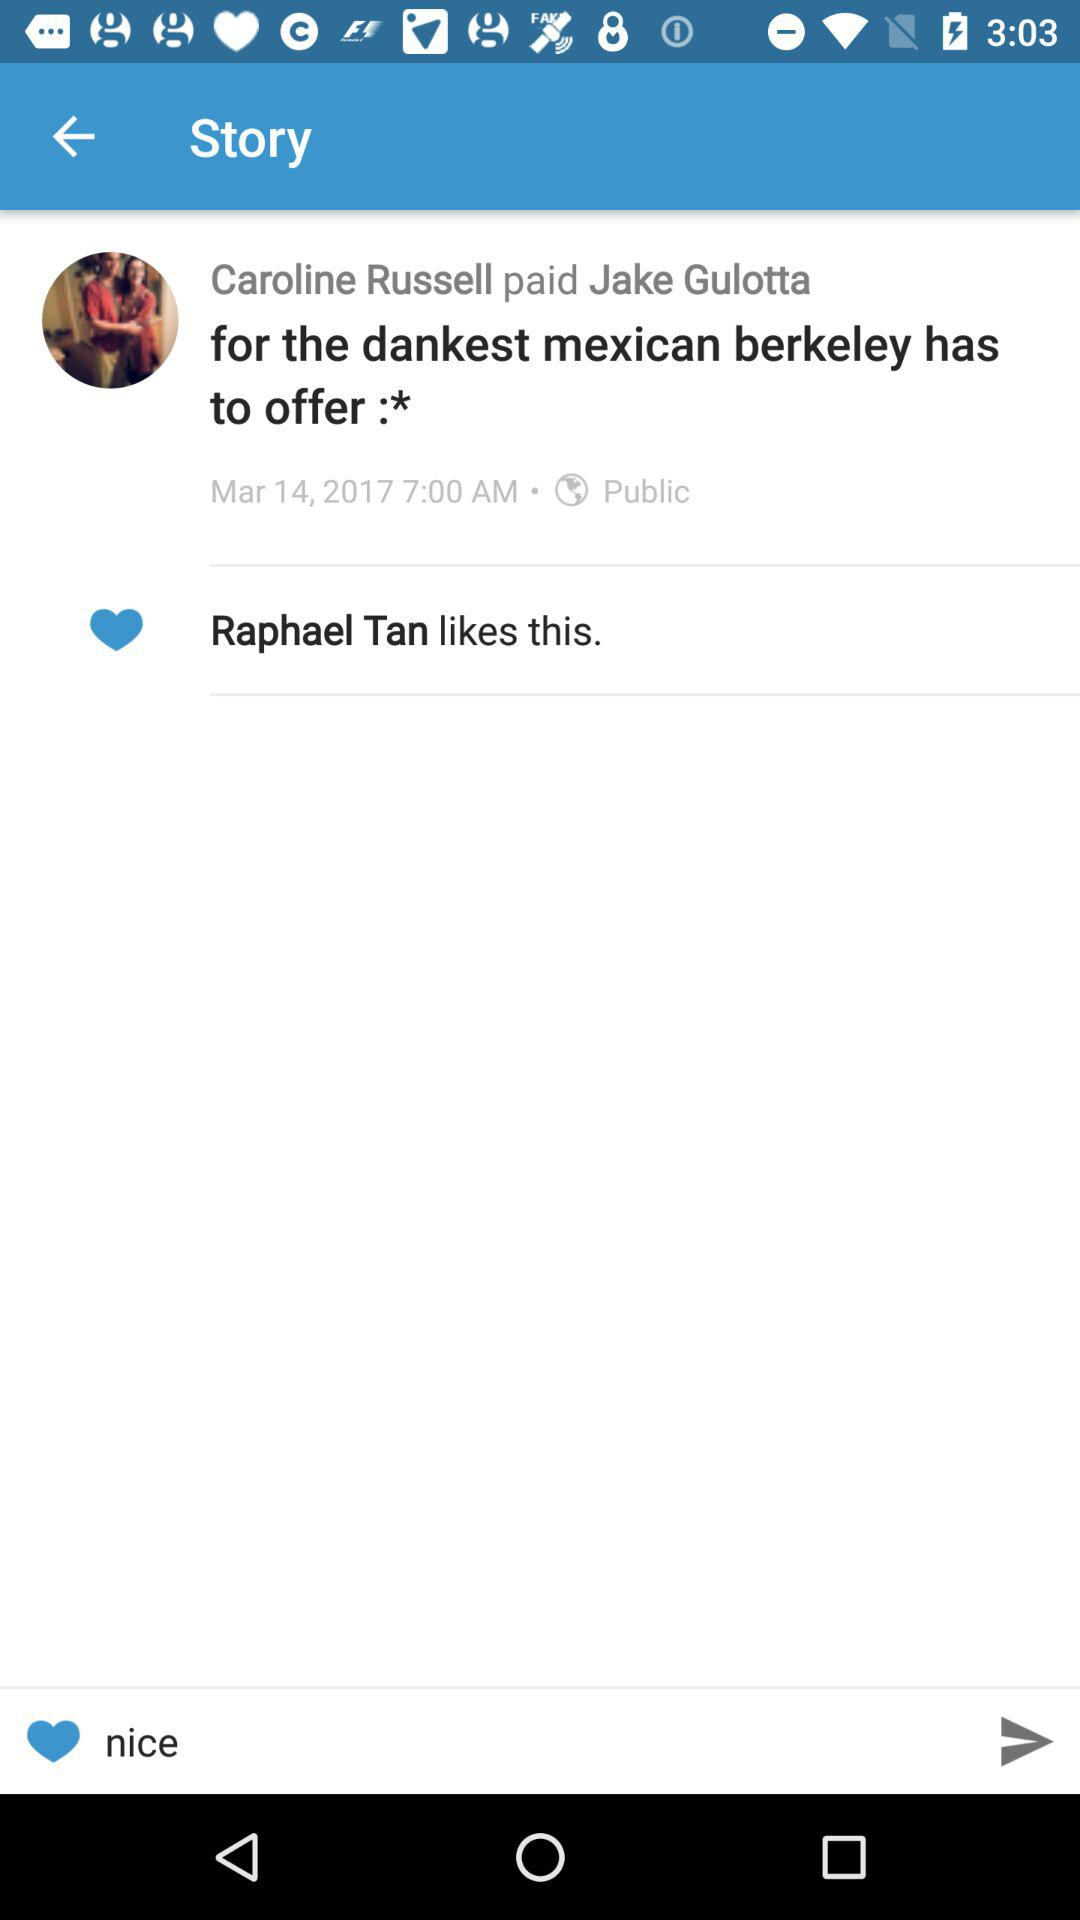Who liked the story? The story was liked by Raphael Tan. 